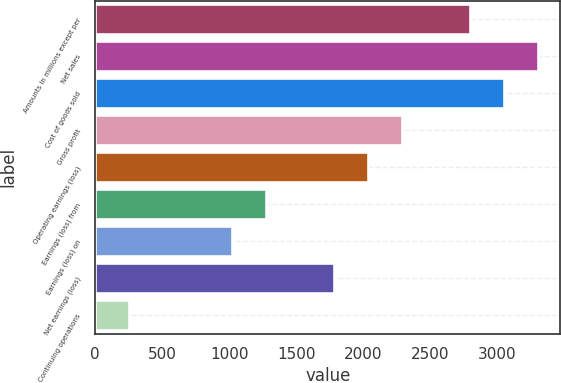Convert chart. <chart><loc_0><loc_0><loc_500><loc_500><bar_chart><fcel>Amounts in millions except per<fcel>Net sales<fcel>Cost of goods sold<fcel>Gross profit<fcel>Operating earnings (loss)<fcel>Earnings (loss) from<fcel>Earnings (loss) on<fcel>Net earnings (loss)<fcel>Continuing operations<nl><fcel>2798.05<fcel>3306.77<fcel>3052.41<fcel>2289.33<fcel>2034.97<fcel>1271.89<fcel>1017.53<fcel>1780.61<fcel>254.45<nl></chart> 